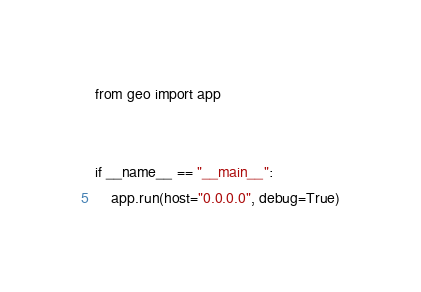Convert code to text. <code><loc_0><loc_0><loc_500><loc_500><_Python_>from geo import app


if __name__ == "__main__":
    app.run(host="0.0.0.0", debug=True)
</code> 